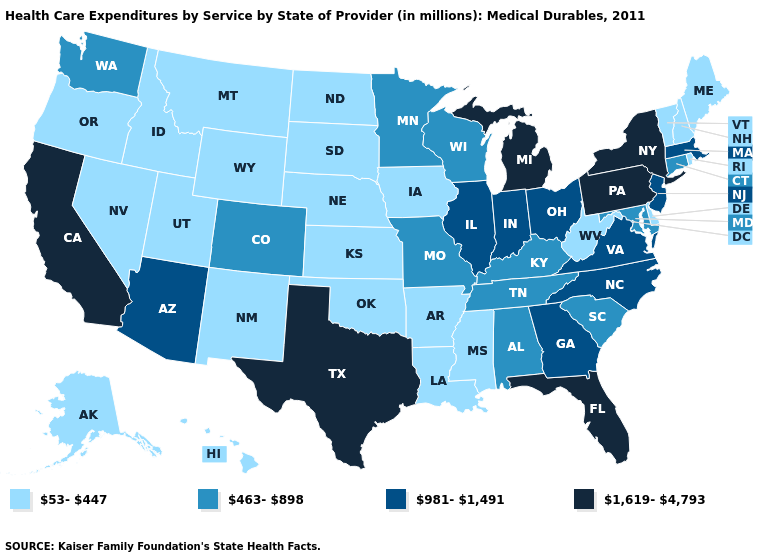Name the states that have a value in the range 463-898?
Give a very brief answer. Alabama, Colorado, Connecticut, Kentucky, Maryland, Minnesota, Missouri, South Carolina, Tennessee, Washington, Wisconsin. Among the states that border New Jersey , does Delaware have the highest value?
Be succinct. No. Name the states that have a value in the range 53-447?
Concise answer only. Alaska, Arkansas, Delaware, Hawaii, Idaho, Iowa, Kansas, Louisiana, Maine, Mississippi, Montana, Nebraska, Nevada, New Hampshire, New Mexico, North Dakota, Oklahoma, Oregon, Rhode Island, South Dakota, Utah, Vermont, West Virginia, Wyoming. Does Rhode Island have the highest value in the Northeast?
Keep it brief. No. Which states have the lowest value in the USA?
Keep it brief. Alaska, Arkansas, Delaware, Hawaii, Idaho, Iowa, Kansas, Louisiana, Maine, Mississippi, Montana, Nebraska, Nevada, New Hampshire, New Mexico, North Dakota, Oklahoma, Oregon, Rhode Island, South Dakota, Utah, Vermont, West Virginia, Wyoming. What is the value of New Hampshire?
Short answer required. 53-447. What is the value of Georgia?
Be succinct. 981-1,491. Name the states that have a value in the range 463-898?
Give a very brief answer. Alabama, Colorado, Connecticut, Kentucky, Maryland, Minnesota, Missouri, South Carolina, Tennessee, Washington, Wisconsin. Among the states that border New York , which have the lowest value?
Concise answer only. Vermont. What is the value of Alabama?
Concise answer only. 463-898. How many symbols are there in the legend?
Short answer required. 4. What is the value of Montana?
Concise answer only. 53-447. Name the states that have a value in the range 1,619-4,793?
Short answer required. California, Florida, Michigan, New York, Pennsylvania, Texas. Does Michigan have the highest value in the MidWest?
Be succinct. Yes. 